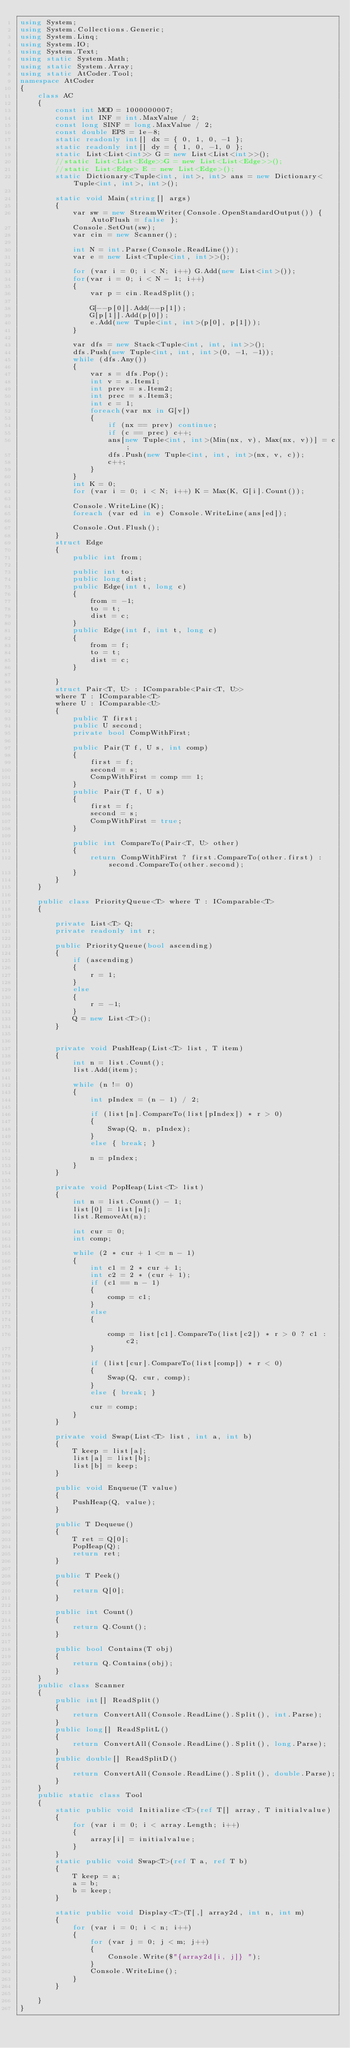<code> <loc_0><loc_0><loc_500><loc_500><_C#_>using System;
using System.Collections.Generic;
using System.Linq;
using System.IO;
using System.Text;
using static System.Math;
using static System.Array;
using static AtCoder.Tool;
namespace AtCoder
{
    class AC
    {
        const int MOD = 1000000007;
        const int INF = int.MaxValue / 2;
        const long SINF = long.MaxValue / 2;
        const double EPS = 1e-8;
        static readonly int[] dx = { 0, 1, 0, -1 };
        static readonly int[] dy = { 1, 0, -1, 0 };
        static List<List<int>> G = new List<List<int>>();
        //static List<List<Edge>>G = new List<List<Edge>>();
        //static List<Edge> E = new List<Edge>();
        static Dictionary<Tuple<int, int>, int> ans = new Dictionary<Tuple<int, int>, int>();

        static void Main(string[] args)
        {
            var sw = new StreamWriter(Console.OpenStandardOutput()) { AutoFlush = false };
            Console.SetOut(sw);
            var cin = new Scanner();

            int N = int.Parse(Console.ReadLine());
            var e = new List<Tuple<int, int>>();

            for (var i = 0; i < N; i++) G.Add(new List<int>());
            for(var i = 0; i < N - 1; i++)
            {
                var p = cin.ReadSplit();
                
                G[--p[0]].Add(--p[1]);
                G[p[1]].Add(p[0]);
                e.Add(new Tuple<int, int>(p[0], p[1]));
            }

            var dfs = new Stack<Tuple<int, int, int>>();
            dfs.Push(new Tuple<int, int, int>(0, -1, -1));
            while (dfs.Any())
            {
                var s = dfs.Pop();
                int v = s.Item1;
                int prev = s.Item2;
                int prec = s.Item3;
                int c = 1;
                foreach(var nx in G[v])
                {
                    if (nx == prev) continue;
                    if (c == prec) c++;
                    ans[new Tuple<int, int>(Min(nx, v), Max(nx, v))] = c;
                    dfs.Push(new Tuple<int, int, int>(nx, v, c));
                    c++;
                }
            }
            int K = 0;
            for (var i = 0; i < N; i++) K = Max(K, G[i].Count());

            Console.WriteLine(K);
            foreach (var ed in e) Console.WriteLine(ans[ed]);

            Console.Out.Flush();
        }
        struct Edge
        {
            public int from;

            public int to;
            public long dist;
            public Edge(int t, long c)
            {
                from = -1;
                to = t;
                dist = c;
            }
            public Edge(int f, int t, long c)
            {
                from = f;
                to = t;
                dist = c;
            }

        }
        struct Pair<T, U> : IComparable<Pair<T, U>>
        where T : IComparable<T>
        where U : IComparable<U>
        {
            public T first;
            public U second;
            private bool CompWithFirst;

            public Pair(T f, U s, int comp)
            {
                first = f;
                second = s;
                CompWithFirst = comp == 1;
            }
            public Pair(T f, U s)
            {
                first = f;
                second = s;
                CompWithFirst = true;
            }

            public int CompareTo(Pair<T, U> other)
            {
                return CompWithFirst ? first.CompareTo(other.first) : second.CompareTo(other.second);
            }
        }
    }

    public class PriorityQueue<T> where T : IComparable<T>
    {

        private List<T> Q;
        private readonly int r;

        public PriorityQueue(bool ascending)
        {
            if (ascending)
            {
                r = 1;
            }
            else
            {
                r = -1;
            }
            Q = new List<T>();
        }


        private void PushHeap(List<T> list, T item)
        {
            int n = list.Count();
            list.Add(item);

            while (n != 0)
            {
                int pIndex = (n - 1) / 2;

                if (list[n].CompareTo(list[pIndex]) * r > 0)
                {
                    Swap(Q, n, pIndex);
                }
                else { break; }

                n = pIndex;
            }
        }

        private void PopHeap(List<T> list)
        {
            int n = list.Count() - 1;
            list[0] = list[n];
            list.RemoveAt(n);

            int cur = 0;
            int comp;

            while (2 * cur + 1 <= n - 1)
            {
                int c1 = 2 * cur + 1;
                int c2 = 2 * (cur + 1);
                if (c1 == n - 1)
                {
                    comp = c1;
                }
                else
                {

                    comp = list[c1].CompareTo(list[c2]) * r > 0 ? c1 : c2;
                }

                if (list[cur].CompareTo(list[comp]) * r < 0)
                {
                    Swap(Q, cur, comp);
                }
                else { break; }

                cur = comp;
            }
        }

        private void Swap(List<T> list, int a, int b)
        {
            T keep = list[a];
            list[a] = list[b];
            list[b] = keep;
        }

        public void Enqueue(T value)
        {
            PushHeap(Q, value);
        }

        public T Dequeue()
        {
            T ret = Q[0];
            PopHeap(Q);
            return ret;
        }

        public T Peek()
        {
            return Q[0];
        }

        public int Count()
        {
            return Q.Count();
        }

        public bool Contains(T obj)
        {
            return Q.Contains(obj);
        }
    }
    public class Scanner
    {
        public int[] ReadSplit()
        {
            return ConvertAll(Console.ReadLine().Split(), int.Parse);
        }
        public long[] ReadSplitL()
        {
            return ConvertAll(Console.ReadLine().Split(), long.Parse);
        }
        public double[] ReadSplitD()
        {
            return ConvertAll(Console.ReadLine().Split(), double.Parse);
        }
    }
    public static class Tool
    {
        static public void Initialize<T>(ref T[] array, T initialvalue)
        {
            for (var i = 0; i < array.Length; i++)
            {
                array[i] = initialvalue;
            }
        }
        static public void Swap<T>(ref T a, ref T b)
        {
            T keep = a;
            a = b;
            b = keep;
        }

        static public void Display<T>(T[,] array2d, int n, int m)
        {
            for (var i = 0; i < n; i++)
            {
                for (var j = 0; j < m; j++)
                {
                    Console.Write($"{array2d[i, j]} ");
                }
                Console.WriteLine();
            }
        }

    }
}
</code> 